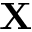Convert formula to latex. <formula><loc_0><loc_0><loc_500><loc_500>X</formula> 